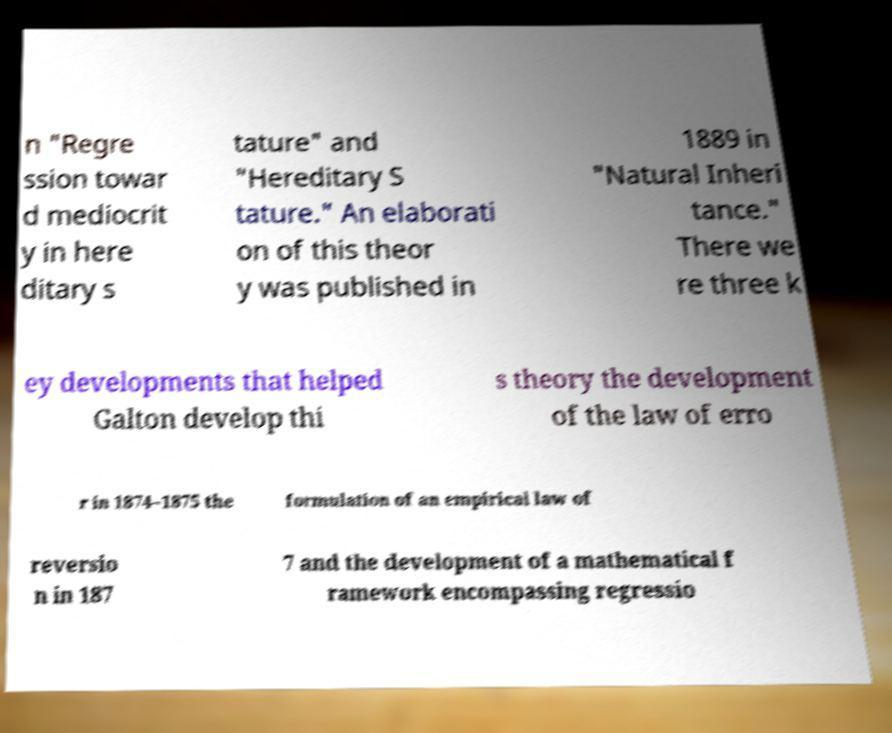Please read and relay the text visible in this image. What does it say? n "Regre ssion towar d mediocrit y in here ditary s tature" and "Hereditary S tature." An elaborati on of this theor y was published in 1889 in "Natural Inheri tance." There we re three k ey developments that helped Galton develop thi s theory the development of the law of erro r in 1874–1875 the formulation of an empirical law of reversio n in 187 7 and the development of a mathematical f ramework encompassing regressio 